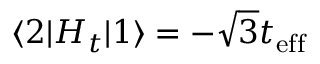<formula> <loc_0><loc_0><loc_500><loc_500>\langle 2 | H _ { t } | 1 \rangle = - \sqrt { 3 } t _ { e f f }</formula> 